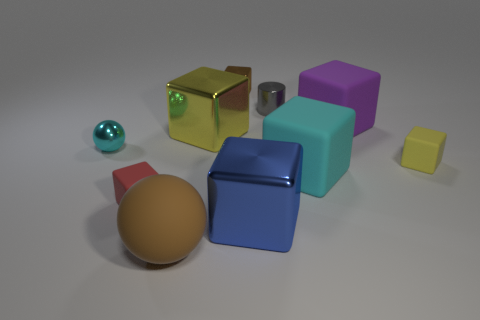There is a tiny metal object that is the same shape as the big cyan rubber thing; what color is it?
Offer a terse response. Brown. Are there the same number of small yellow matte blocks to the left of the blue object and shiny objects?
Ensure brevity in your answer.  No. What number of cylinders are big blue things or gray shiny things?
Ensure brevity in your answer.  1. There is a big sphere that is the same material as the small yellow cube; what color is it?
Your answer should be very brief. Brown. Does the large purple thing have the same material as the cyan thing that is to the right of the tiny shiny ball?
Make the answer very short. Yes. What number of objects are either big rubber blocks or small yellow rubber balls?
Give a very brief answer. 2. What material is the big cube that is the same color as the small metallic ball?
Provide a succinct answer. Rubber. Is there another small thing of the same shape as the purple matte object?
Your answer should be compact. Yes. What number of red matte things are left of the big brown ball?
Give a very brief answer. 1. What material is the brown object that is to the right of the yellow cube that is on the left side of the big purple thing?
Provide a short and direct response. Metal. 